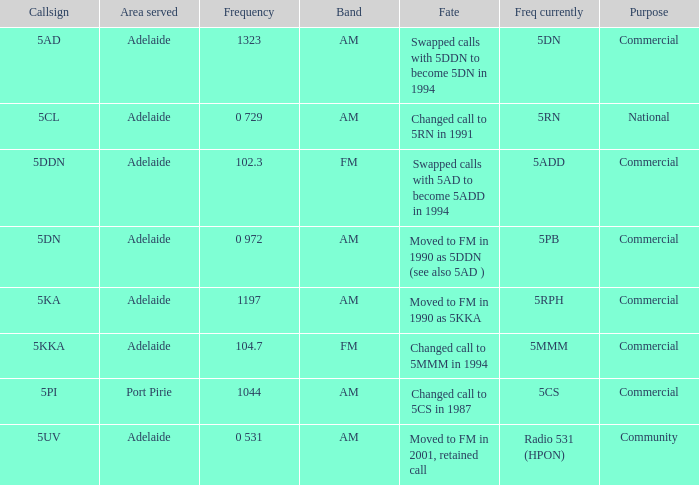Which area served has a Callsign of 5ddn? Adelaide. 